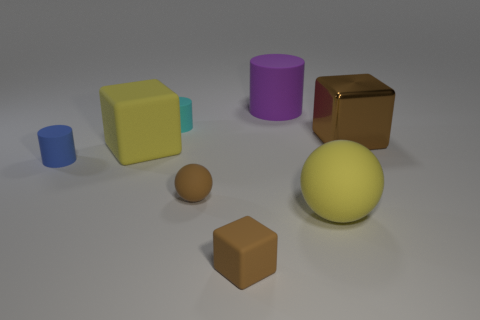Add 2 yellow matte cubes. How many objects exist? 10 Subtract all purple cylinders. How many cylinders are left? 2 Subtract all matte blocks. How many blocks are left? 1 Subtract all purple balls. How many blue cylinders are left? 1 Subtract all big blue shiny objects. Subtract all big yellow blocks. How many objects are left? 7 Add 8 blue things. How many blue things are left? 9 Add 3 blue objects. How many blue objects exist? 4 Subtract 1 brown blocks. How many objects are left? 7 Subtract all spheres. How many objects are left? 6 Subtract 2 cubes. How many cubes are left? 1 